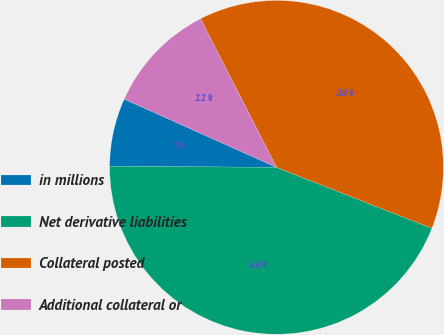Convert chart. <chart><loc_0><loc_0><loc_500><loc_500><pie_chart><fcel>in millions<fcel>Net derivative liabilities<fcel>Collateral posted<fcel>Additional collateral or<nl><fcel>6.6%<fcel>44.15%<fcel>38.47%<fcel>10.77%<nl></chart> 